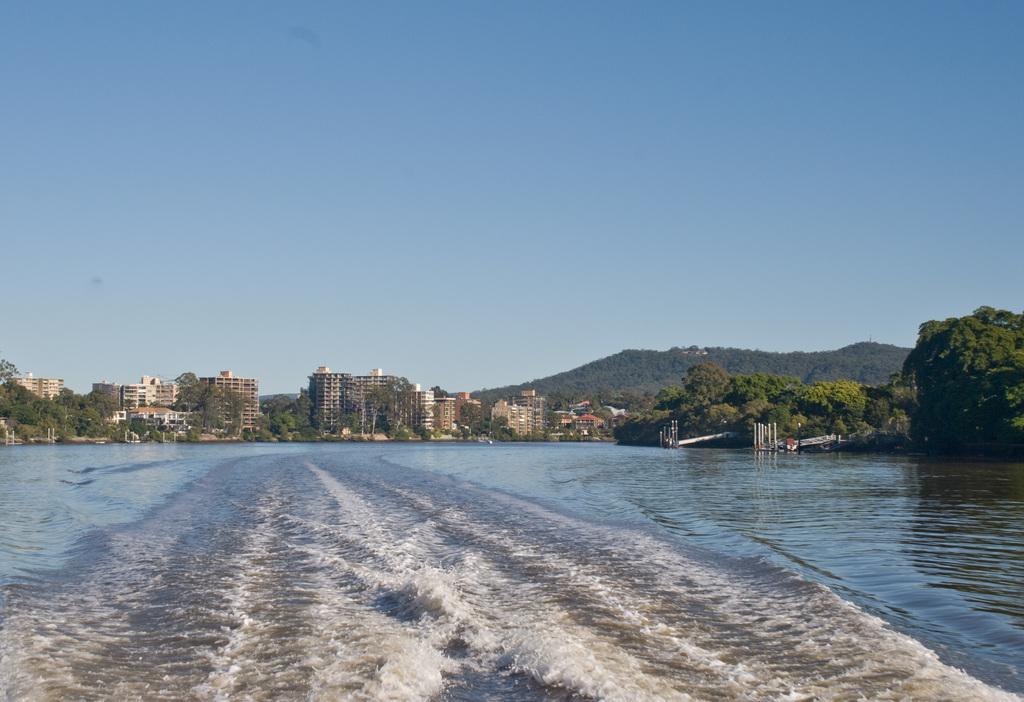In one or two sentences, can you explain what this image depicts? In this image there is a river in the middle. In the background there are so many buildings one beside the other. At the top there is the sky. On the right side there are two bridges in the water, Behind them there are hills. There are trees in between the buildings. 